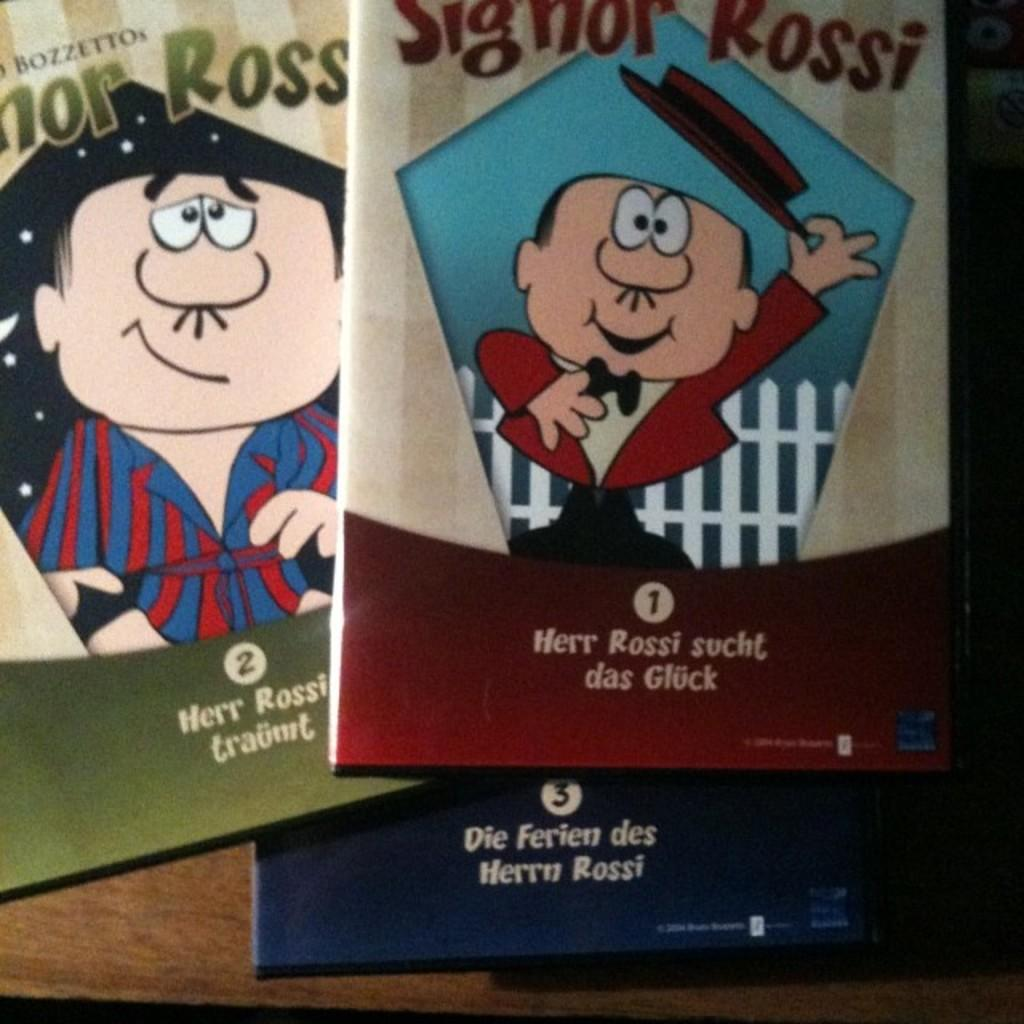What can be found on the book covers in the image? There are words and cartoon images on the book covers. What type of object are the book covers placed on? The book covers are on a wooden object. What type of vacation is being planned by the women in the image? There are no women or any indication of a vacation in the image; it only features book covers on a wooden object. 